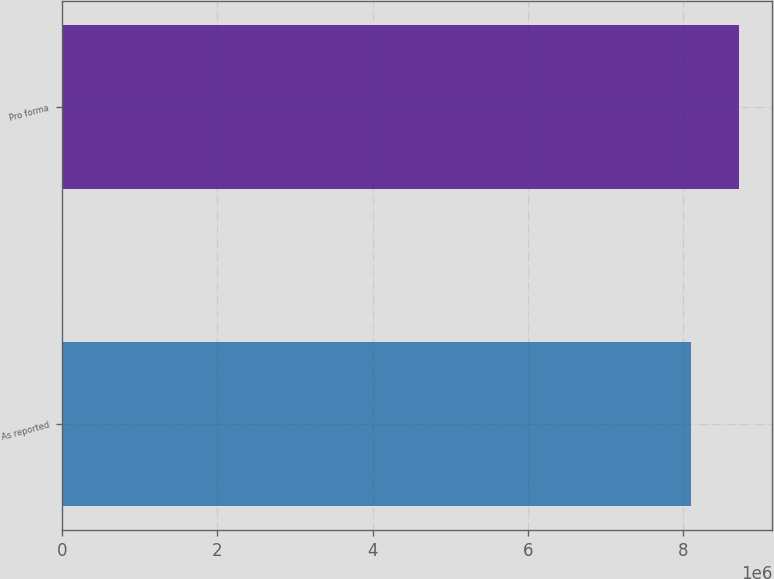<chart> <loc_0><loc_0><loc_500><loc_500><bar_chart><fcel>As reported<fcel>Pro forma<nl><fcel>8.10434e+06<fcel>8.71205e+06<nl></chart> 